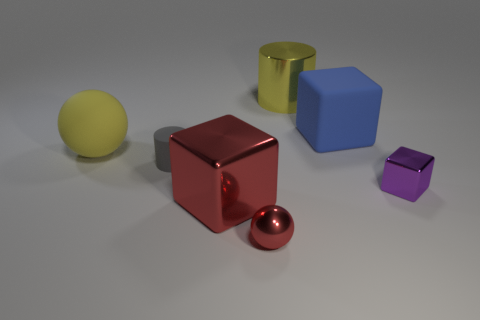What is the shape of the big shiny object that is the same color as the large rubber ball?
Make the answer very short. Cylinder. There is a metal sphere that is the same color as the large metallic block; what size is it?
Your answer should be compact. Small. What is the shape of the large shiny object behind the yellow matte sphere?
Provide a short and direct response. Cylinder. Are there any red things behind the ball on the right side of the small gray rubber cylinder?
Your answer should be very brief. Yes. The big object that is both right of the big red block and to the left of the big blue cube is what color?
Provide a succinct answer. Yellow. Is there a large yellow object that is right of the cylinder in front of the large shiny thing behind the red block?
Offer a terse response. Yes. What size is the red thing that is the same shape as the big yellow rubber object?
Your answer should be very brief. Small. Is there a big block?
Ensure brevity in your answer.  Yes. Do the large sphere and the large shiny object right of the red metal block have the same color?
Provide a short and direct response. Yes. There is a yellow thing that is in front of the large metal object behind the cylinder in front of the yellow cylinder; what is its size?
Your answer should be very brief. Large. 